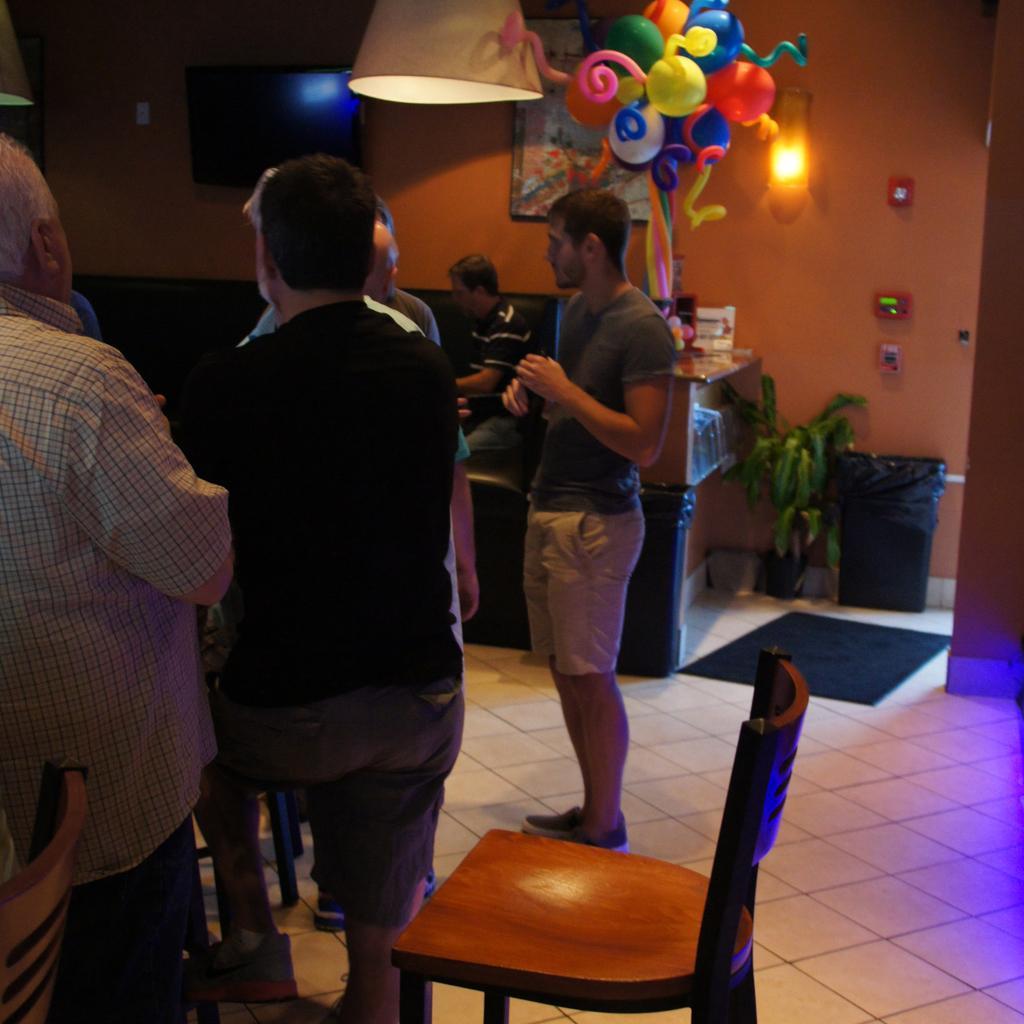Describe this image in one or two sentences. There is a floor of white color and a chair of brown color and some people are standing and in the there is a wall of orange color on that wall there is a lamp and a switches in red color and some balloons and a light hanging on the roof. 